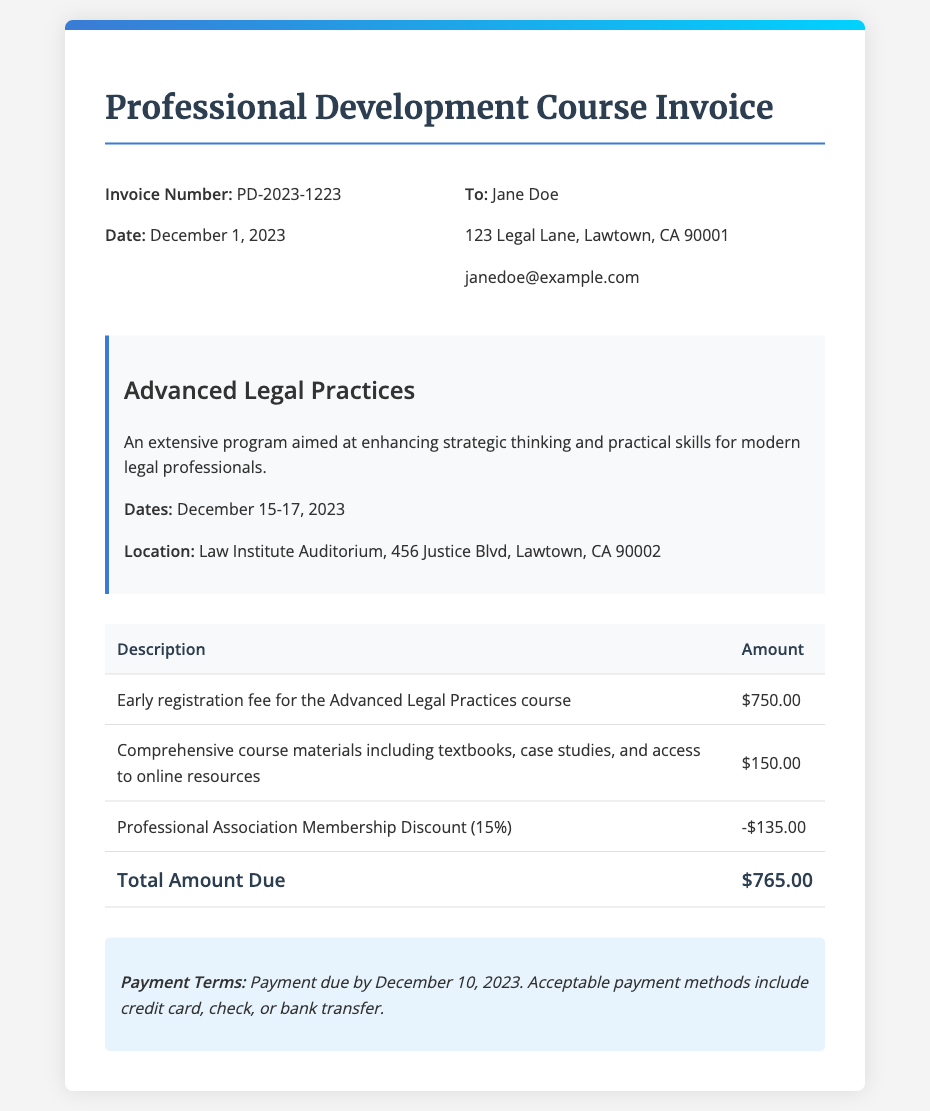What is the invoice number? The invoice number is provided at the top of the document as a unique identifier, which is PD-2023-1223.
Answer: PD-2023-1223 What is the date of the invoice? The date of the invoice is clearly stated near the invoice number, which is December 1, 2023.
Answer: December 1, 2023 Who is the recipient of this invoice? The recipient's name is listed in the recipient details section, which is Jane Doe.
Answer: Jane Doe What is the total amount due? The total amount due is calculated and listed in the table as the final total, which is $765.00.
Answer: $765.00 What is the registration fee for the course? The registration fee for the course is specified in the invoice details as the early registration fee, which is $750.00.
Answer: $750.00 What discount was applied to the invoice? The discount applied is detailed in the items listed, which is the Professional Association Membership Discount of 15%.
Answer: 15% By what date is payment due? The payment terms section specifies the payment due date, which is December 10, 2023.
Answer: December 10, 2023 Where is the course being held? The location of the course is mentioned in the course details section, which is the Law Institute Auditorium, 456 Justice Blvd, Lawtown, CA 90002.
Answer: Law Institute Auditorium, 456 Justice Blvd, Lawtown, CA 90002 What is included in the course materials? The course materials include details that specify they encompass textbooks, case studies, and access to online resources.
Answer: Textbooks, case studies, and access to online resources 